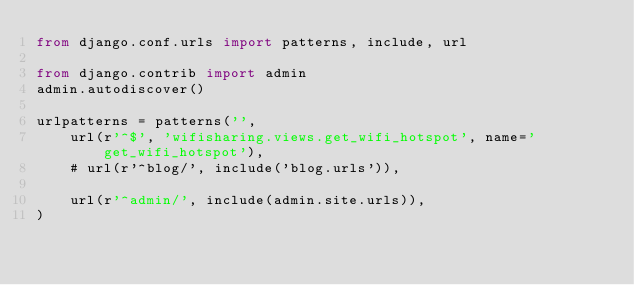Convert code to text. <code><loc_0><loc_0><loc_500><loc_500><_Python_>from django.conf.urls import patterns, include, url

from django.contrib import admin
admin.autodiscover()

urlpatterns = patterns('',
    url(r'^$', 'wifisharing.views.get_wifi_hotspot', name='get_wifi_hotspot'),
    # url(r'^blog/', include('blog.urls')),

    url(r'^admin/', include(admin.site.urls)),
)
</code> 